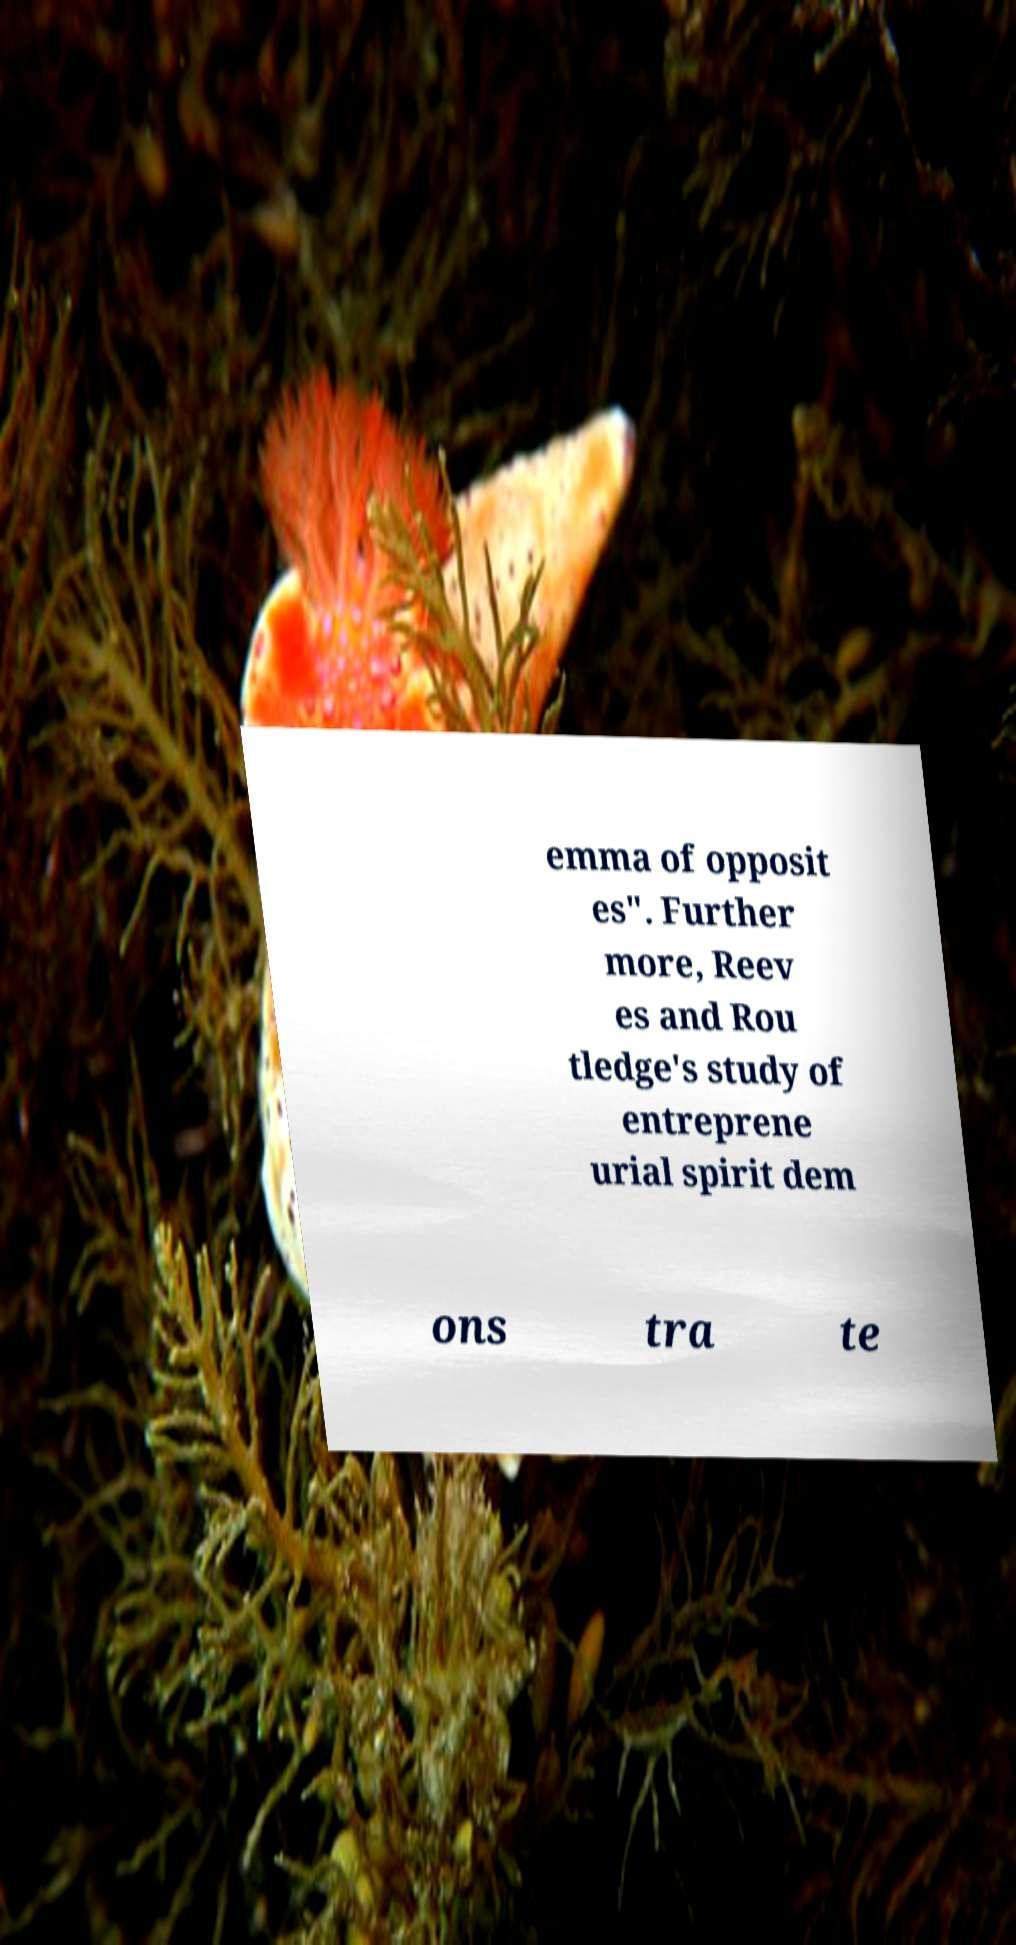Could you assist in decoding the text presented in this image and type it out clearly? emma of opposit es". Further more, Reev es and Rou tledge's study of entreprene urial spirit dem ons tra te 